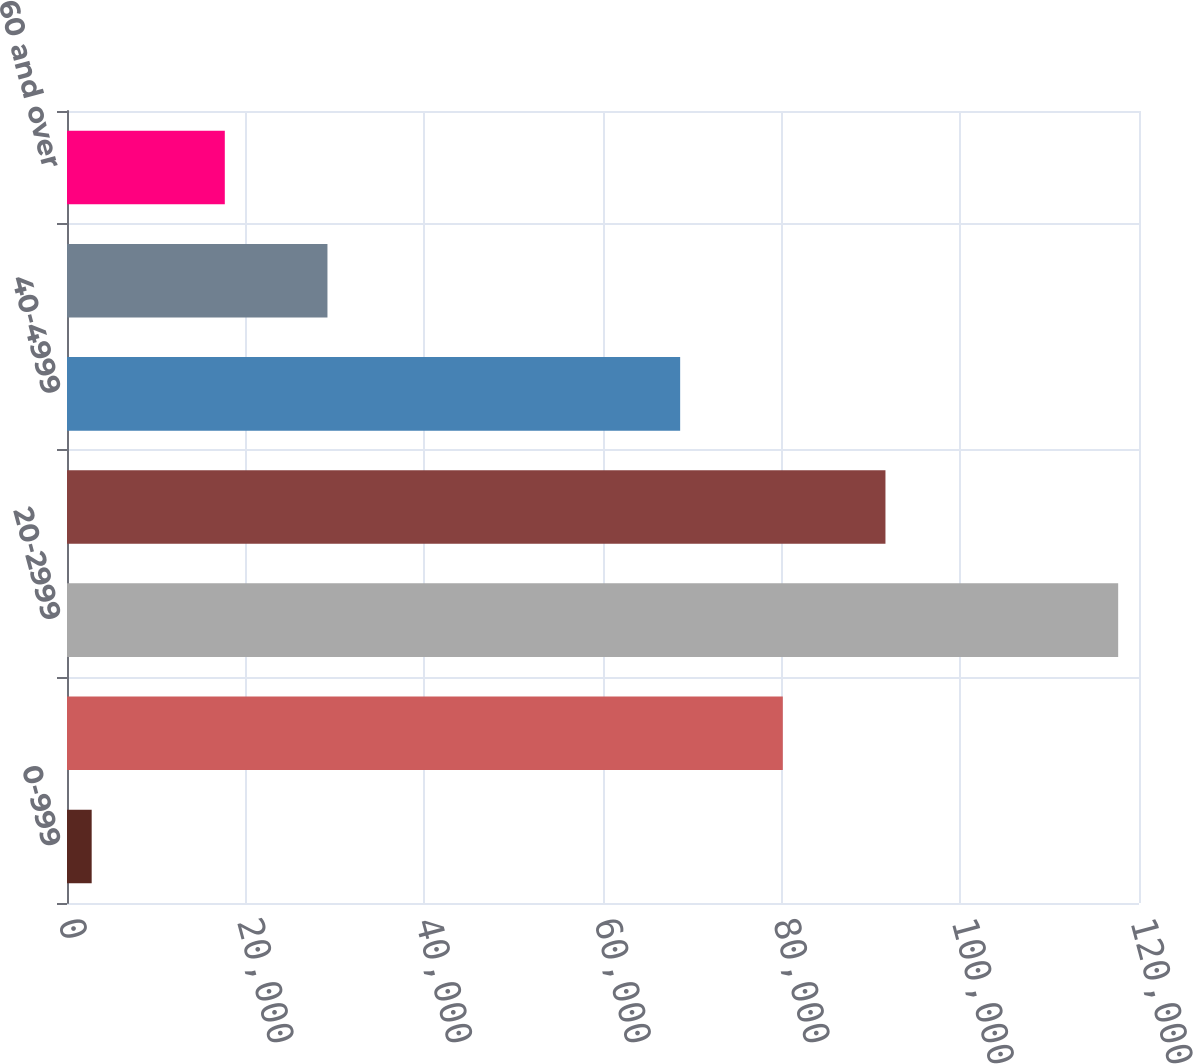Convert chart. <chart><loc_0><loc_0><loc_500><loc_500><bar_chart><fcel>0-999<fcel>10-1999<fcel>20-2999<fcel>30-3999<fcel>40-4999<fcel>50-5999<fcel>60 and over<nl><fcel>2763<fcel>80127.6<fcel>117669<fcel>91618.2<fcel>68637<fcel>29155.6<fcel>17665<nl></chart> 